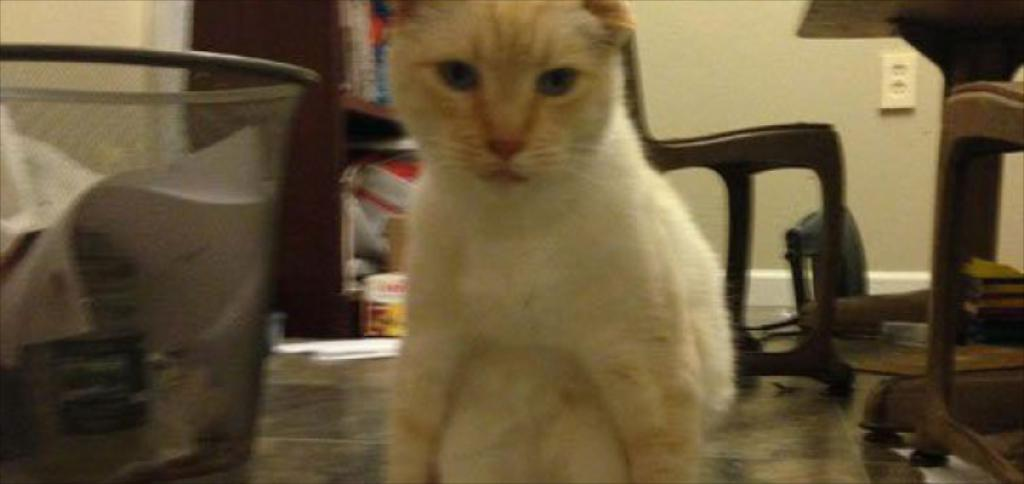What type of animal can be seen in the image? There is a cat in the image. What type of furniture is present in the image? There is a table and a chair in the image. What type of structure is visible in the image? There is a wall in the image. What other unspecified objects can be seen in the image? There are some unspecified objects in the image. What invention is the cat using to kick a ball in the image? There is no invention or ball present in the image; it only features a cat, table, chair, wall, and unspecified objects. 